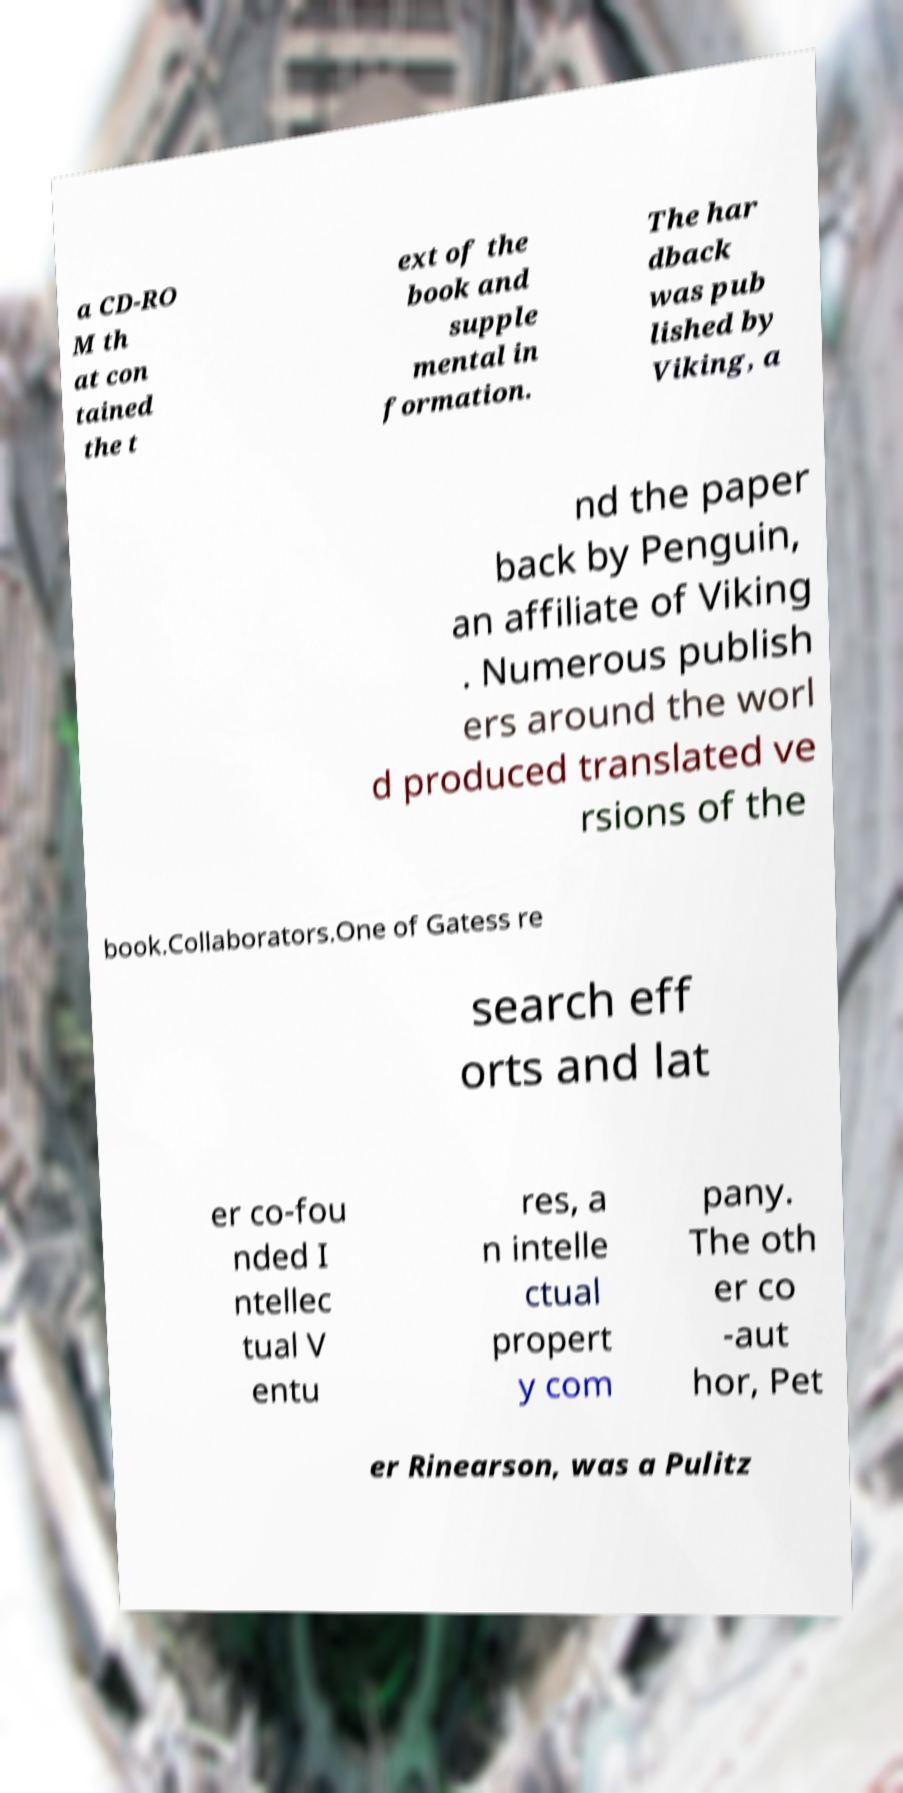What messages or text are displayed in this image? I need them in a readable, typed format. a CD-RO M th at con tained the t ext of the book and supple mental in formation. The har dback was pub lished by Viking, a nd the paper back by Penguin, an affiliate of Viking . Numerous publish ers around the worl d produced translated ve rsions of the book.Collaborators.One of Gatess re search eff orts and lat er co-fou nded I ntellec tual V entu res, a n intelle ctual propert y com pany. The oth er co -aut hor, Pet er Rinearson, was a Pulitz 